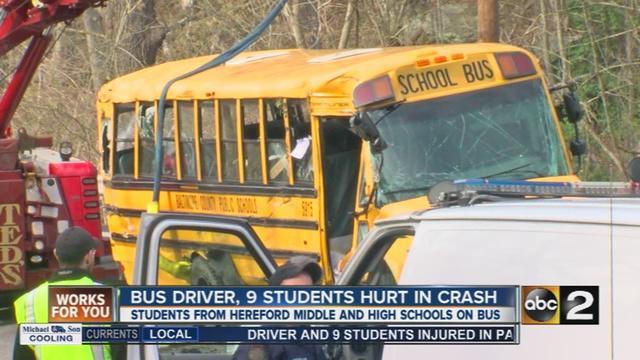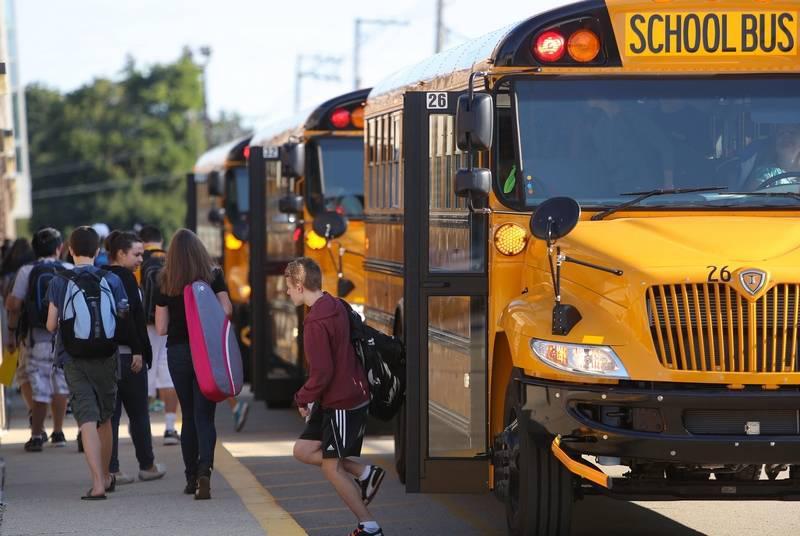The first image is the image on the left, the second image is the image on the right. Assess this claim about the two images: "The right image includes at least one adult and at least two young children by the open doors of a bus parked diagonally facing right, and the left image shows at least two teens with backpacks to the left of a bus with an open door.". Correct or not? Answer yes or no. No. The first image is the image on the left, the second image is the image on the right. Assess this claim about the two images: "An officer stands outside of the bus in the image on the right.". Correct or not? Answer yes or no. No. 